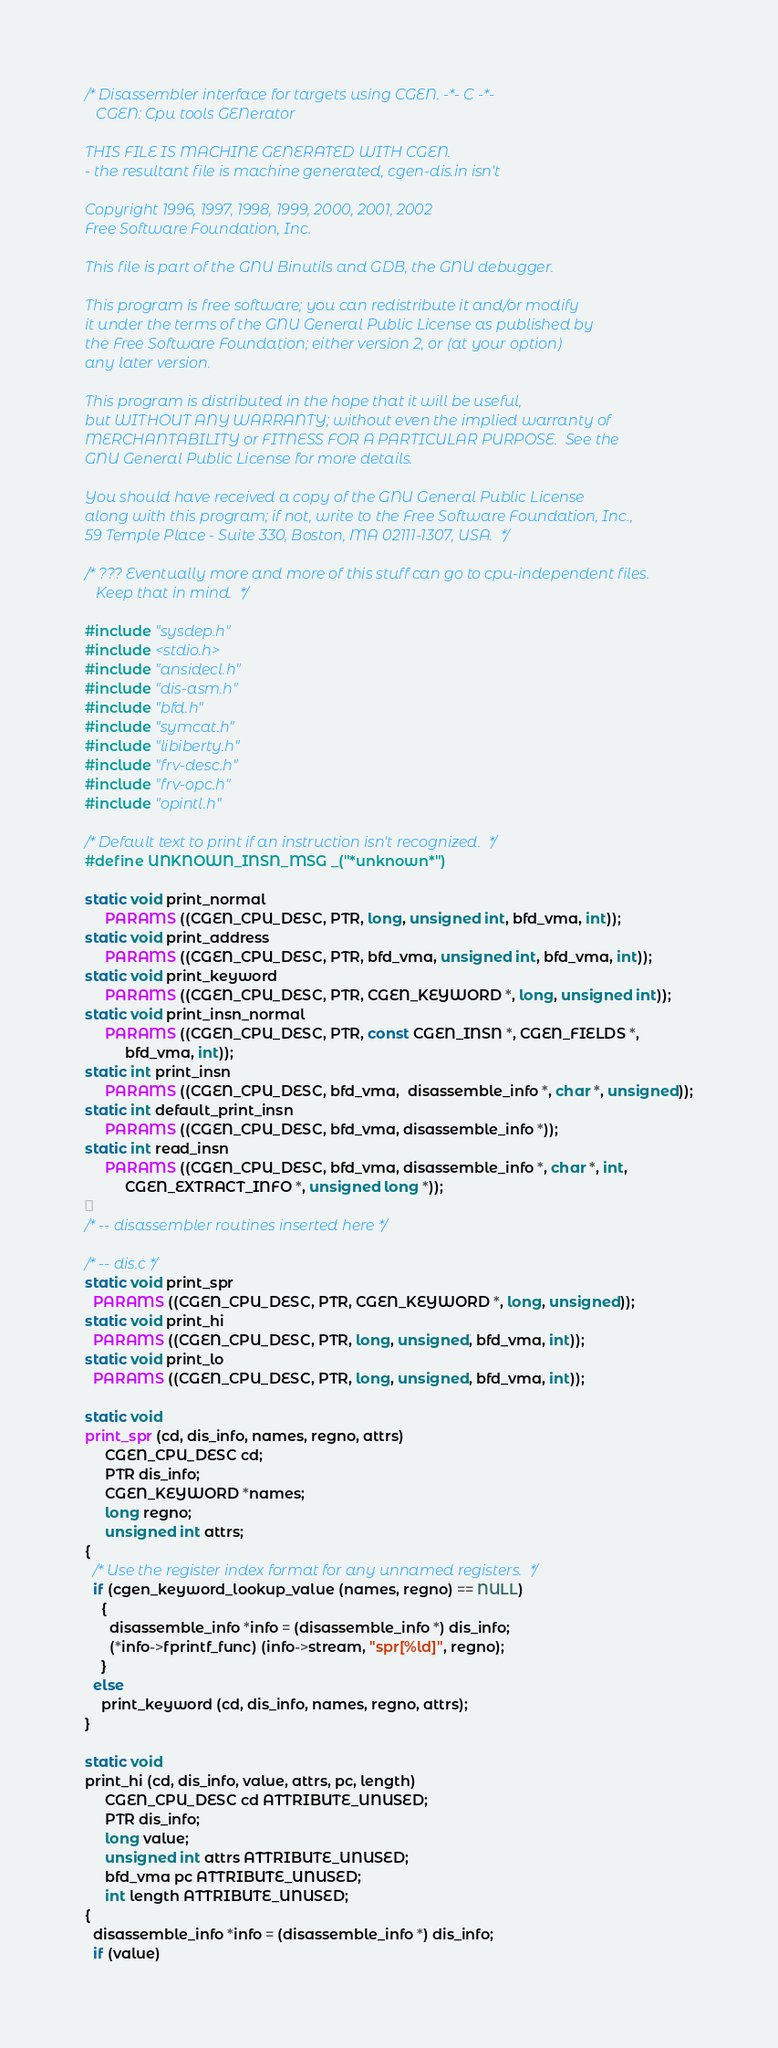<code> <loc_0><loc_0><loc_500><loc_500><_C_>/* Disassembler interface for targets using CGEN. -*- C -*-
   CGEN: Cpu tools GENerator

THIS FILE IS MACHINE GENERATED WITH CGEN.
- the resultant file is machine generated, cgen-dis.in isn't

Copyright 1996, 1997, 1998, 1999, 2000, 2001, 2002
Free Software Foundation, Inc.

This file is part of the GNU Binutils and GDB, the GNU debugger.

This program is free software; you can redistribute it and/or modify
it under the terms of the GNU General Public License as published by
the Free Software Foundation; either version 2, or (at your option)
any later version.

This program is distributed in the hope that it will be useful,
but WITHOUT ANY WARRANTY; without even the implied warranty of
MERCHANTABILITY or FITNESS FOR A PARTICULAR PURPOSE.  See the
GNU General Public License for more details.

You should have received a copy of the GNU General Public License
along with this program; if not, write to the Free Software Foundation, Inc.,
59 Temple Place - Suite 330, Boston, MA 02111-1307, USA.  */

/* ??? Eventually more and more of this stuff can go to cpu-independent files.
   Keep that in mind.  */

#include "sysdep.h"
#include <stdio.h>
#include "ansidecl.h"
#include "dis-asm.h"
#include "bfd.h"
#include "symcat.h"
#include "libiberty.h"
#include "frv-desc.h"
#include "frv-opc.h"
#include "opintl.h"

/* Default text to print if an instruction isn't recognized.  */
#define UNKNOWN_INSN_MSG _("*unknown*")

static void print_normal
     PARAMS ((CGEN_CPU_DESC, PTR, long, unsigned int, bfd_vma, int));
static void print_address
     PARAMS ((CGEN_CPU_DESC, PTR, bfd_vma, unsigned int, bfd_vma, int));
static void print_keyword
     PARAMS ((CGEN_CPU_DESC, PTR, CGEN_KEYWORD *, long, unsigned int));
static void print_insn_normal
     PARAMS ((CGEN_CPU_DESC, PTR, const CGEN_INSN *, CGEN_FIELDS *,
	      bfd_vma, int));
static int print_insn
     PARAMS ((CGEN_CPU_DESC, bfd_vma,  disassemble_info *, char *, unsigned));
static int default_print_insn
     PARAMS ((CGEN_CPU_DESC, bfd_vma, disassemble_info *));
static int read_insn
     PARAMS ((CGEN_CPU_DESC, bfd_vma, disassemble_info *, char *, int,
	      CGEN_EXTRACT_INFO *, unsigned long *));

/* -- disassembler routines inserted here */

/* -- dis.c */
static void print_spr
  PARAMS ((CGEN_CPU_DESC, PTR, CGEN_KEYWORD *, long, unsigned));
static void print_hi
  PARAMS ((CGEN_CPU_DESC, PTR, long, unsigned, bfd_vma, int));
static void print_lo
  PARAMS ((CGEN_CPU_DESC, PTR, long, unsigned, bfd_vma, int));

static void
print_spr (cd, dis_info, names, regno, attrs)
     CGEN_CPU_DESC cd;
     PTR dis_info;
     CGEN_KEYWORD *names;
     long regno;
     unsigned int attrs;
{
  /* Use the register index format for any unnamed registers.  */
  if (cgen_keyword_lookup_value (names, regno) == NULL)
    {
      disassemble_info *info = (disassemble_info *) dis_info;
      (*info->fprintf_func) (info->stream, "spr[%ld]", regno);
    }
  else
    print_keyword (cd, dis_info, names, regno, attrs);
}

static void
print_hi (cd, dis_info, value, attrs, pc, length)
     CGEN_CPU_DESC cd ATTRIBUTE_UNUSED;
     PTR dis_info;
     long value;
     unsigned int attrs ATTRIBUTE_UNUSED;
     bfd_vma pc ATTRIBUTE_UNUSED;
     int length ATTRIBUTE_UNUSED;
{
  disassemble_info *info = (disassemble_info *) dis_info;
  if (value)</code> 